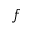<formula> <loc_0><loc_0><loc_500><loc_500>f</formula> 